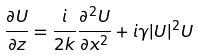<formula> <loc_0><loc_0><loc_500><loc_500>\frac { \partial U } { \partial z } = \frac { i } { 2 k } \frac { \partial ^ { 2 } U } { \partial x ^ { 2 } } + i \gamma | U | ^ { 2 } U</formula> 